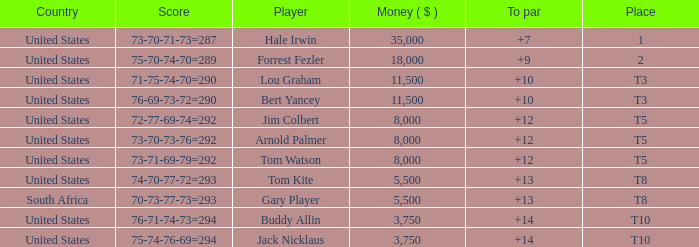Which country's score of 72-77-69-74=292 resulted in a reward of over $5,500? United States. 